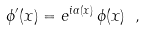<formula> <loc_0><loc_0><loc_500><loc_500>\phi ^ { \prime } ( x ) = e ^ { i \alpha ( x ) } \, \phi ( x ) \ ,</formula> 